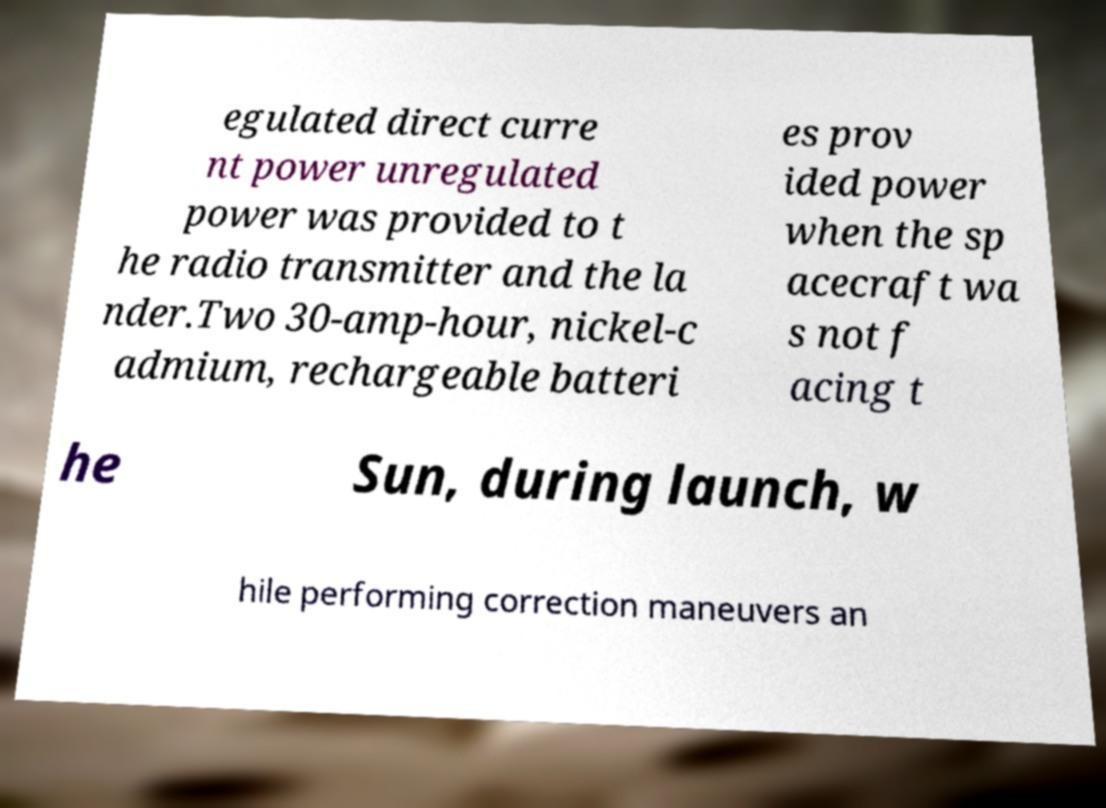Can you read and provide the text displayed in the image?This photo seems to have some interesting text. Can you extract and type it out for me? egulated direct curre nt power unregulated power was provided to t he radio transmitter and the la nder.Two 30-amp-hour, nickel-c admium, rechargeable batteri es prov ided power when the sp acecraft wa s not f acing t he Sun, during launch, w hile performing correction maneuvers an 